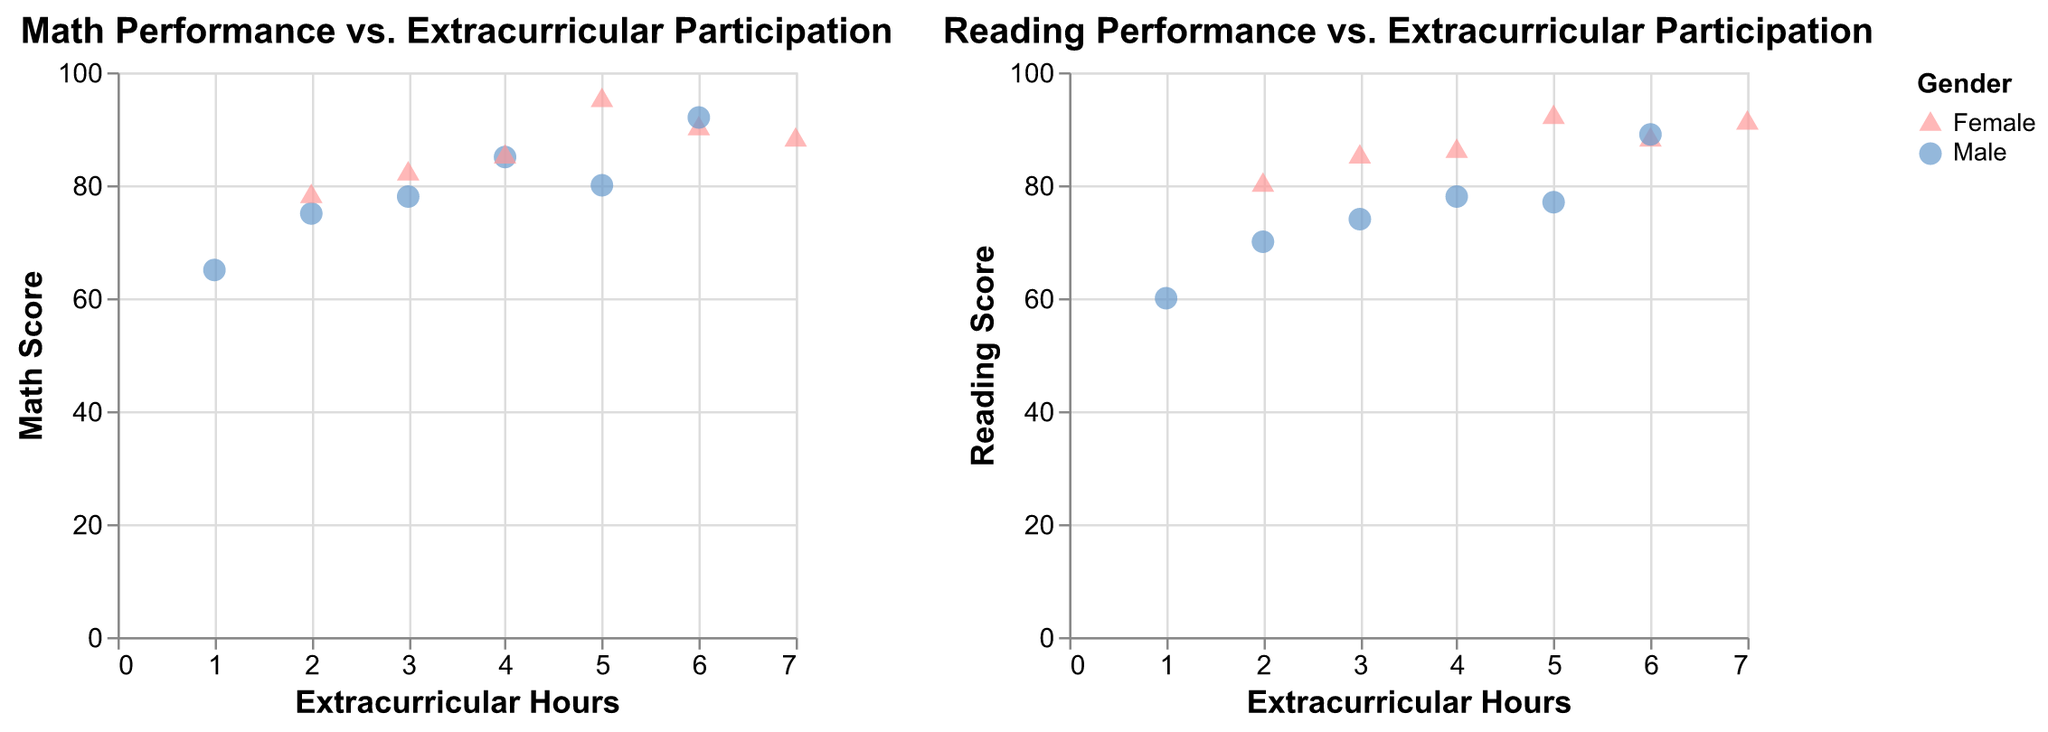How many students are represented in the figure? Count the number of data points in either subplot. Both subplots contain data points for all 12 students.
Answer: 12 Which student has the highest extracurricular participation? Look for the highest value on the Extracurricular Hours axis in either subplot. Sophia Martin has 7 extracurricular hours, the highest in the dataset.
Answer: Sophia Martin Are there more male or female students with extracurricular hours greater than 4? Count the number of male and female data points with Extracurricular Hours > 4 in either subplot. Two male students (John Smith, David Martinez) and three female students (Jane Doe, Emily White, Sophia Martin).
Answer: Female students Is there a visible trend between extracurricular participation and reading scores among female students? In the Reading Performance vs. Extracurricular Participation subplot, observe if female data points (triangles) show a pattern. Most female data points trend upwards as extracurricular hours increase, suggesting a positive correlation.
Answer: Yes What is the math score of the student with the lowest extracurricular participation? Look for the lowest point on the Extracurricular Hours axis in the Math Performance subplot. William Lee has 1 hour and a Math Score of 65.
Answer: 65 Which gender shows a higher average reading score with equal extracurricular participation? Average the Reading Scores for male and female students with identical Extracurricular Hours in the Reading Performance subplot. For example, John Smith (78) and Olivia Garcia (86) both have 4 hours—female student averages are higher.
Answer: Female students How does John Smith's math score compare to James Wilson's math score? Locate both students' data points in the Math Performance subplot. John Smith has a score of 85, and James Wilson has a score of 80.
Answer: Higher Do any students have the same extracurricular hours and show distinct gender differences in reading scores? Compare male and female data points with identical Extracurricular Hours in the Reading Performance subplot. John Smith (78) and Olivia Garcia (86) both have 4 hours, showing a difference in reading scores.
Answer: Yes What is the reading score range among students with 5 extracurricular hours? Identify students with 5 hours in the Reading Performance subplot and find their reading scores: Emily White (92), James Wilson (77). Calculate the range (92 - 77).
Answer: 15 Is there any student whose math score is lower than their reading score, with the same extracurricular participation? Check both subplots and compare Math and Reading Scores for students with identical Extracurricular Hours. For instance, Michael Johnson (Math: 78, Reading: 74) does not match the criteria, but John Smith (85, 78) does.
Answer: No 